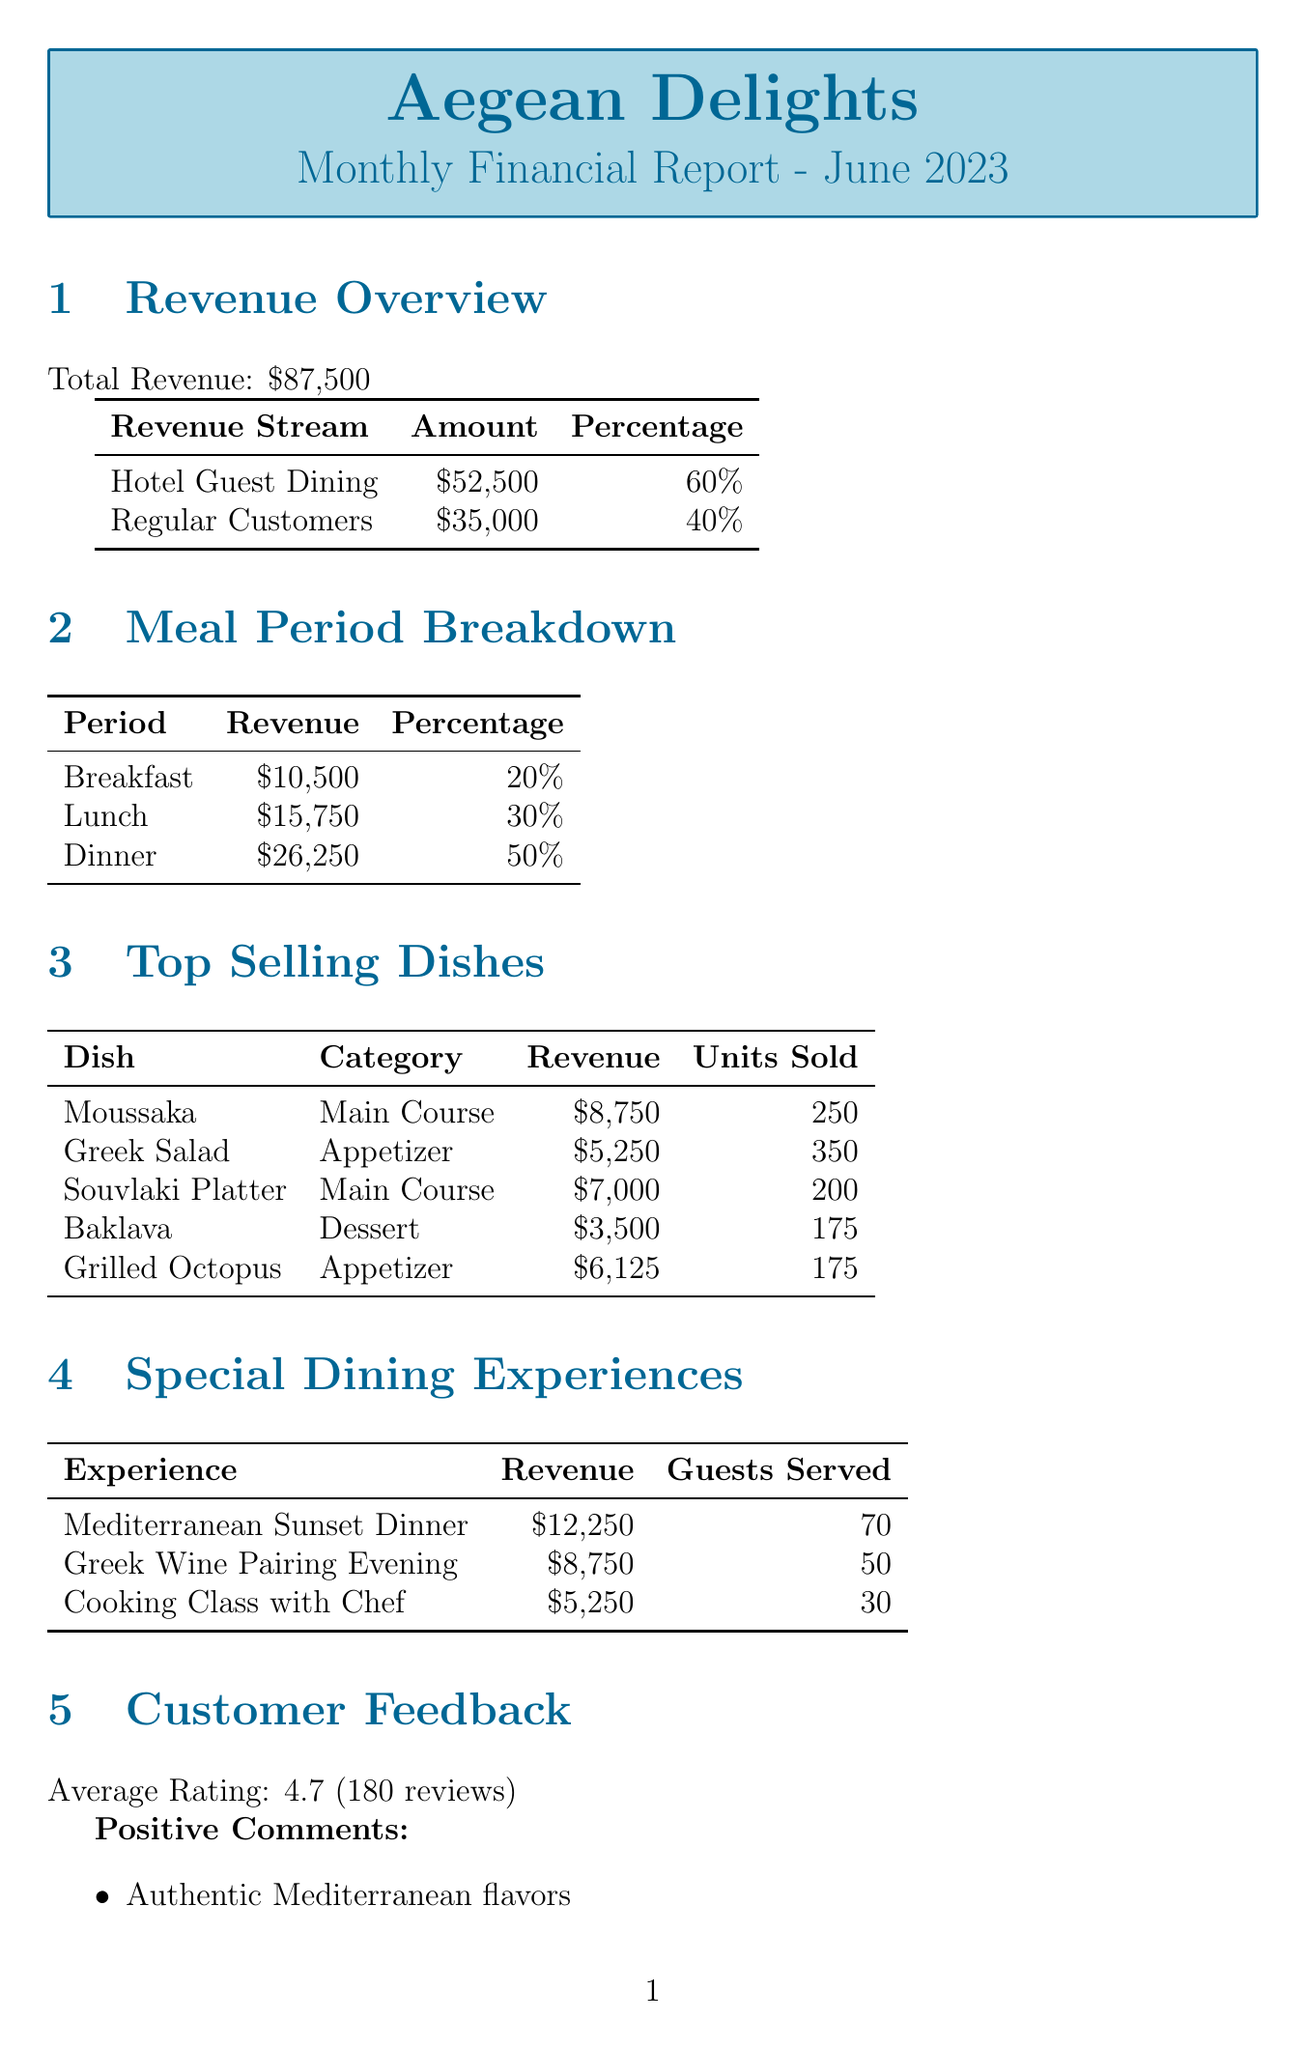what is the total revenue? The total revenue is $87,500 as stated in the document.
Answer: $87,500 what percentage of total revenue comes from hotel guest dining? The document states that hotel guest dining accounts for 60% of the total revenue.
Answer: 60% how much revenue did the Mediterranean Sunset Dinner generate? The Mediterranean Sunset Dinner revenue is reported to be $12,250.
Answer: $12,250 what is the average customer feedback rating? The document indicates that the average rating from customer feedback is 4.7.
Answer: 4.7 which meal period generated the highest revenue? The highest revenue meal period is Dinner, with a revenue of $26,250.
Answer: Dinner how many guests were served for the Greek Wine Pairing Evening? The document states that 50 guests were served for this dining experience.
Answer: 50 what is the food cost percentage mentioned in the report? The food cost percentage provided in the operational insights is 28%.
Answer: 28% what is the top-selling appetizer according to units sold? The top-selling appetizer is Greek Salad, with 350 units sold.
Answer: Greek Salad how many special dining experiences are detailed in the report? The report details three special dining experiences.
Answer: three 